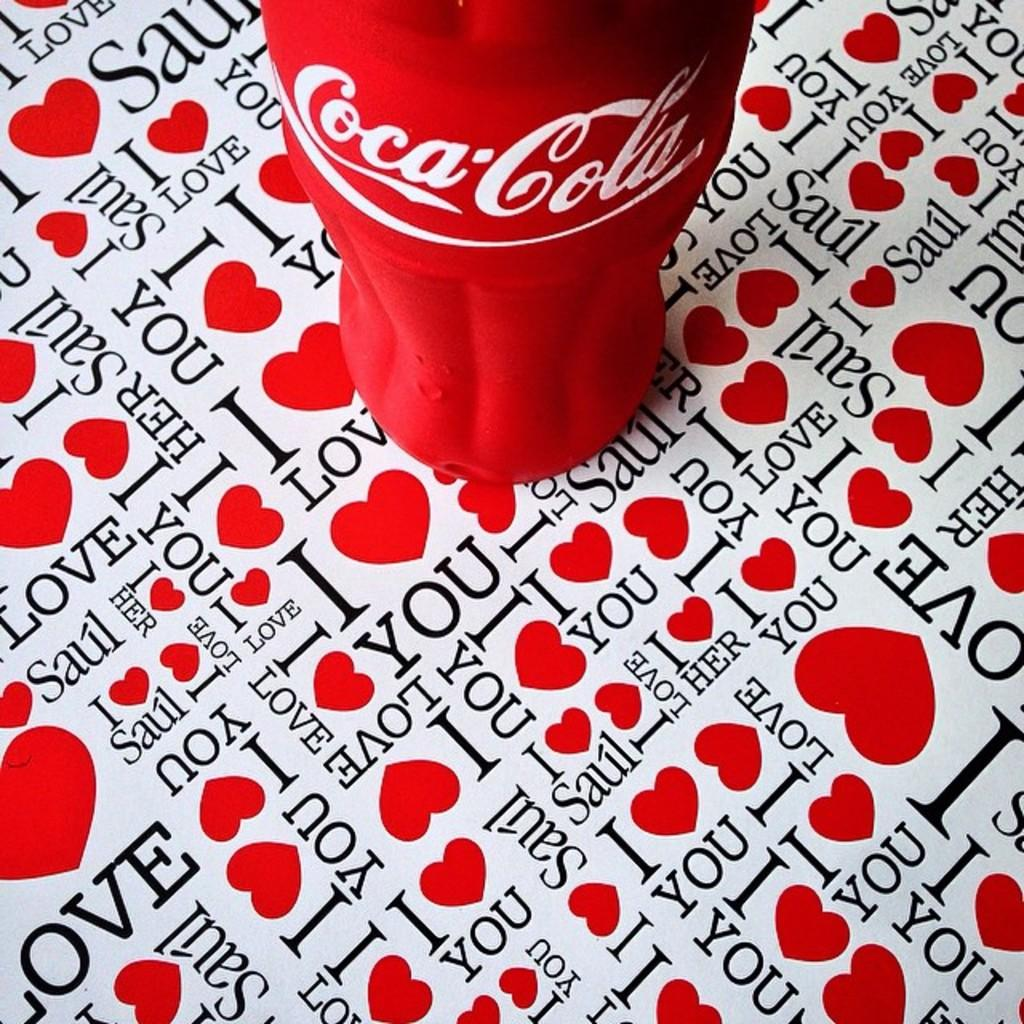What is the color of the Coca-Cola bottle in the image? The Coca-Cola bottle in the image is red. Where is the Coca-Cola bottle located in the image? The Coca-Cola bottle is placed on a table top. What type of army is depicted in the image? There is no army depicted in the image; it features a red Coca-Cola bottle on a table top. What kind of joke is being told in the image? There is no joke being told in the image; it features a red Coca-Cola bottle on a table top. 